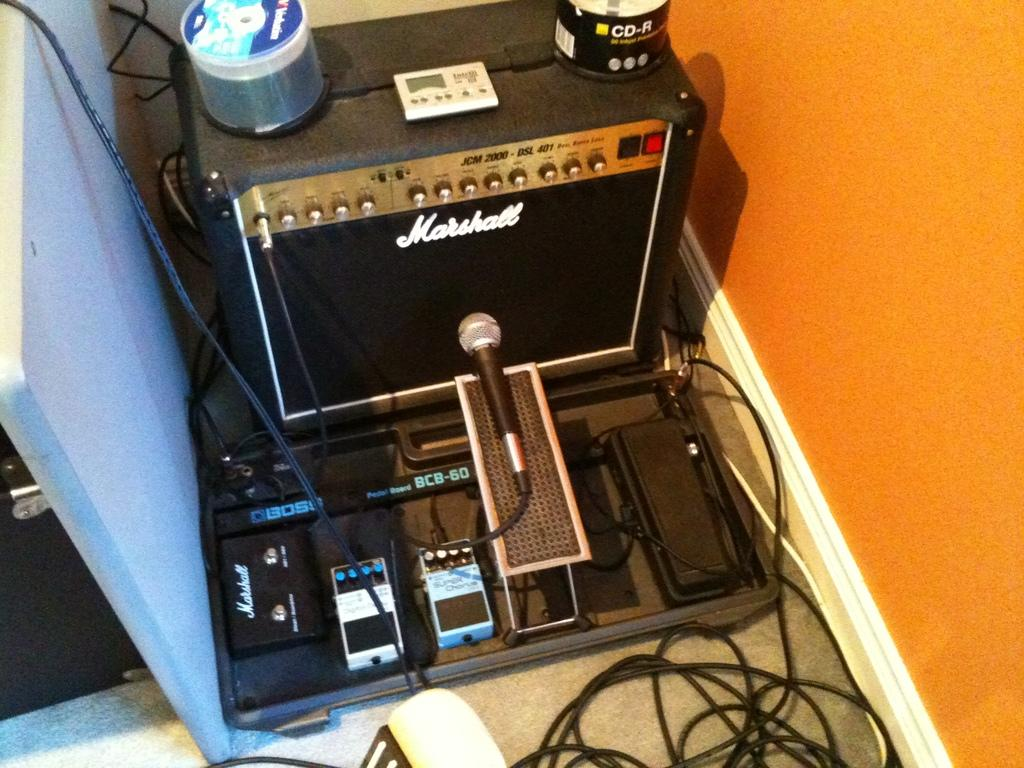What is the main object located at the top of the image? There is a device on the top of the image. What can be found at the bottom of the image? There is a microphone (mike) at the bottom of the image. Are there any visible wires in the image? Yes, there are wires visible at the bottom right of the image. What type of quiver is present in the image? There is no quiver present in the image. How does the behavior of the device change throughout the image? The image is a static representation, so the behavior of the device does not change. 